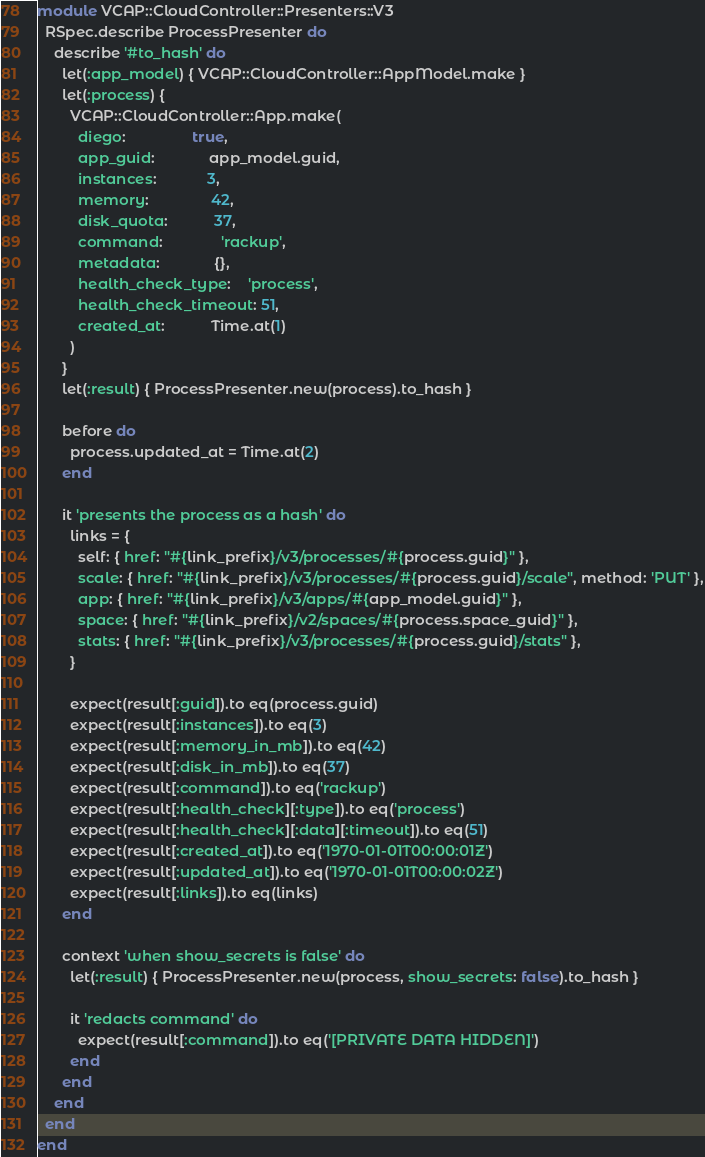<code> <loc_0><loc_0><loc_500><loc_500><_Ruby_>module VCAP::CloudController::Presenters::V3
  RSpec.describe ProcessPresenter do
    describe '#to_hash' do
      let(:app_model) { VCAP::CloudController::AppModel.make }
      let(:process) {
        VCAP::CloudController::App.make(
          diego:                true,
          app_guid:             app_model.guid,
          instances:            3,
          memory:               42,
          disk_quota:           37,
          command:              'rackup',
          metadata:             {},
          health_check_type:    'process',
          health_check_timeout: 51,
          created_at:           Time.at(1)
        )
      }
      let(:result) { ProcessPresenter.new(process).to_hash }

      before do
        process.updated_at = Time.at(2)
      end

      it 'presents the process as a hash' do
        links = {
          self: { href: "#{link_prefix}/v3/processes/#{process.guid}" },
          scale: { href: "#{link_prefix}/v3/processes/#{process.guid}/scale", method: 'PUT' },
          app: { href: "#{link_prefix}/v3/apps/#{app_model.guid}" },
          space: { href: "#{link_prefix}/v2/spaces/#{process.space_guid}" },
          stats: { href: "#{link_prefix}/v3/processes/#{process.guid}/stats" },
        }

        expect(result[:guid]).to eq(process.guid)
        expect(result[:instances]).to eq(3)
        expect(result[:memory_in_mb]).to eq(42)
        expect(result[:disk_in_mb]).to eq(37)
        expect(result[:command]).to eq('rackup')
        expect(result[:health_check][:type]).to eq('process')
        expect(result[:health_check][:data][:timeout]).to eq(51)
        expect(result[:created_at]).to eq('1970-01-01T00:00:01Z')
        expect(result[:updated_at]).to eq('1970-01-01T00:00:02Z')
        expect(result[:links]).to eq(links)
      end

      context 'when show_secrets is false' do
        let(:result) { ProcessPresenter.new(process, show_secrets: false).to_hash }

        it 'redacts command' do
          expect(result[:command]).to eq('[PRIVATE DATA HIDDEN]')
        end
      end
    end
  end
end
</code> 